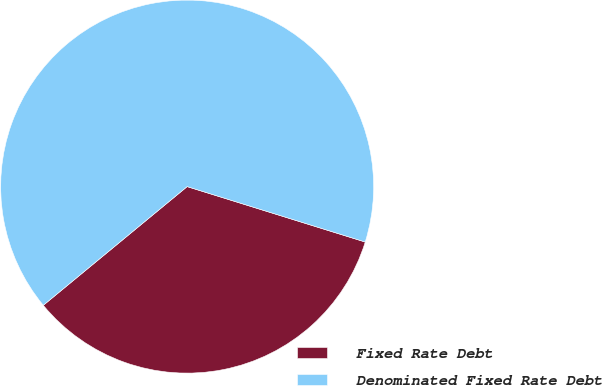<chart> <loc_0><loc_0><loc_500><loc_500><pie_chart><fcel>Fixed Rate Debt<fcel>Denominated Fixed Rate Debt<nl><fcel>34.22%<fcel>65.78%<nl></chart> 